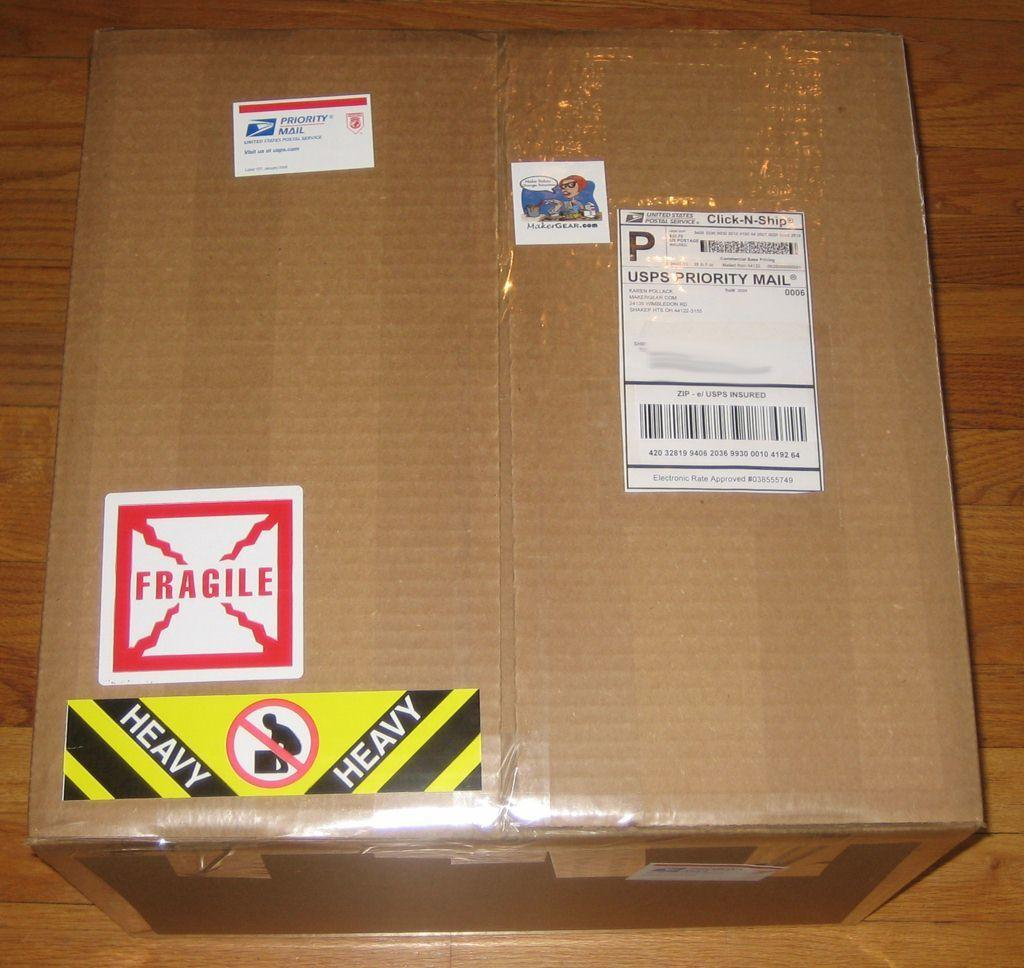<image>
Render a clear and concise summary of the photo. a unopened box shipped from usps priority mail 